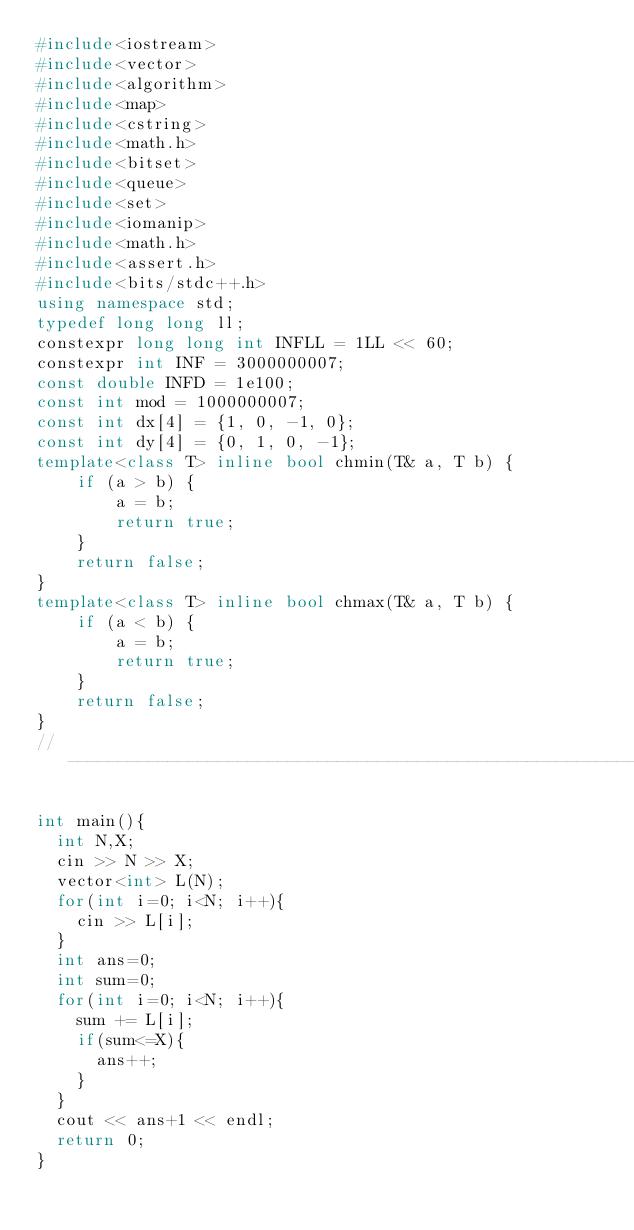Convert code to text. <code><loc_0><loc_0><loc_500><loc_500><_C++_>#include<iostream>
#include<vector>
#include<algorithm>
#include<map>
#include<cstring>
#include<math.h>
#include<bitset>
#include<queue>
#include<set>
#include<iomanip>
#include<math.h>
#include<assert.h>
#include<bits/stdc++.h>
using namespace std;
typedef long long ll;
constexpr long long int INFLL = 1LL << 60;
constexpr int INF = 3000000007;
const double INFD = 1e100;
const int mod = 1000000007;
const int dx[4] = {1, 0, -1, 0};
const int dy[4] = {0, 1, 0, -1};
template<class T> inline bool chmin(T& a, T b) {
    if (a > b) {
        a = b;
        return true;
    }
    return false;
}
template<class T> inline bool chmax(T& a, T b) {
    if (a < b) {
        a = b;
        return true;
    }
    return false;
}
// ----------------------------------------------------------------------------

int main(){
  int N,X;
  cin >> N >> X;
  vector<int> L(N);
  for(int i=0; i<N; i++){
    cin >> L[i];
  }
  int ans=0;
  int sum=0;
  for(int i=0; i<N; i++){
    sum += L[i];
    if(sum<=X){
      ans++;
    }
  }
  cout << ans+1 << endl;
  return 0;
}
</code> 